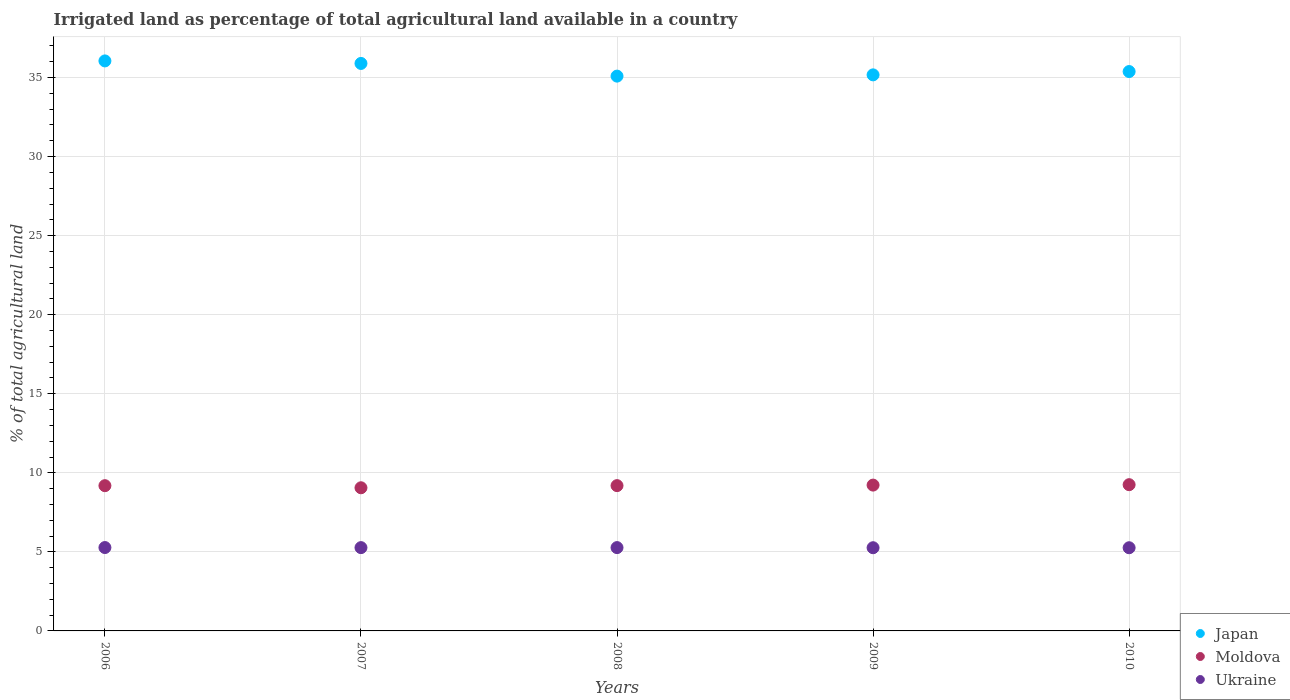How many different coloured dotlines are there?
Give a very brief answer. 3. What is the percentage of irrigated land in Ukraine in 2007?
Provide a succinct answer. 5.27. Across all years, what is the maximum percentage of irrigated land in Ukraine?
Make the answer very short. 5.27. Across all years, what is the minimum percentage of irrigated land in Moldova?
Offer a terse response. 9.05. In which year was the percentage of irrigated land in Japan maximum?
Offer a very short reply. 2006. What is the total percentage of irrigated land in Japan in the graph?
Give a very brief answer. 177.59. What is the difference between the percentage of irrigated land in Ukraine in 2007 and that in 2009?
Keep it short and to the point. 0.01. What is the difference between the percentage of irrigated land in Ukraine in 2007 and the percentage of irrigated land in Japan in 2008?
Your response must be concise. -29.82. What is the average percentage of irrigated land in Moldova per year?
Your response must be concise. 9.18. In the year 2008, what is the difference between the percentage of irrigated land in Japan and percentage of irrigated land in Ukraine?
Offer a very short reply. 29.82. In how many years, is the percentage of irrigated land in Ukraine greater than 32 %?
Offer a very short reply. 0. What is the ratio of the percentage of irrigated land in Moldova in 2009 to that in 2010?
Your answer should be very brief. 1. What is the difference between the highest and the second highest percentage of irrigated land in Moldova?
Your answer should be compact. 0.03. What is the difference between the highest and the lowest percentage of irrigated land in Moldova?
Your answer should be very brief. 0.2. In how many years, is the percentage of irrigated land in Japan greater than the average percentage of irrigated land in Japan taken over all years?
Your answer should be very brief. 2. Is it the case that in every year, the sum of the percentage of irrigated land in Japan and percentage of irrigated land in Ukraine  is greater than the percentage of irrigated land in Moldova?
Give a very brief answer. Yes. Does the percentage of irrigated land in Ukraine monotonically increase over the years?
Your response must be concise. No. Is the percentage of irrigated land in Moldova strictly greater than the percentage of irrigated land in Japan over the years?
Provide a short and direct response. No. How many dotlines are there?
Offer a very short reply. 3. How many years are there in the graph?
Offer a very short reply. 5. What is the difference between two consecutive major ticks on the Y-axis?
Provide a short and direct response. 5. Are the values on the major ticks of Y-axis written in scientific E-notation?
Give a very brief answer. No. Does the graph contain grids?
Offer a very short reply. Yes. Where does the legend appear in the graph?
Provide a succinct answer. Bottom right. What is the title of the graph?
Make the answer very short. Irrigated land as percentage of total agricultural land available in a country. Does "Czech Republic" appear as one of the legend labels in the graph?
Your response must be concise. No. What is the label or title of the X-axis?
Offer a very short reply. Years. What is the label or title of the Y-axis?
Provide a succinct answer. % of total agricultural land. What is the % of total agricultural land in Japan in 2006?
Keep it short and to the point. 36.05. What is the % of total agricultural land in Moldova in 2006?
Make the answer very short. 9.19. What is the % of total agricultural land of Ukraine in 2006?
Provide a succinct answer. 5.27. What is the % of total agricultural land of Japan in 2007?
Provide a succinct answer. 35.89. What is the % of total agricultural land of Moldova in 2007?
Your answer should be compact. 9.05. What is the % of total agricultural land of Ukraine in 2007?
Provide a short and direct response. 5.27. What is the % of total agricultural land in Japan in 2008?
Your answer should be very brief. 35.09. What is the % of total agricultural land in Moldova in 2008?
Your response must be concise. 9.19. What is the % of total agricultural land in Ukraine in 2008?
Make the answer very short. 5.27. What is the % of total agricultural land in Japan in 2009?
Give a very brief answer. 35.17. What is the % of total agricultural land in Moldova in 2009?
Your answer should be compact. 9.22. What is the % of total agricultural land in Ukraine in 2009?
Offer a very short reply. 5.26. What is the % of total agricultural land of Japan in 2010?
Offer a terse response. 35.38. What is the % of total agricultural land in Moldova in 2010?
Offer a terse response. 9.25. What is the % of total agricultural land of Ukraine in 2010?
Your answer should be compact. 5.26. Across all years, what is the maximum % of total agricultural land in Japan?
Offer a very short reply. 36.05. Across all years, what is the maximum % of total agricultural land of Moldova?
Provide a succinct answer. 9.25. Across all years, what is the maximum % of total agricultural land of Ukraine?
Ensure brevity in your answer.  5.27. Across all years, what is the minimum % of total agricultural land in Japan?
Offer a terse response. 35.09. Across all years, what is the minimum % of total agricultural land of Moldova?
Offer a terse response. 9.05. Across all years, what is the minimum % of total agricultural land of Ukraine?
Your response must be concise. 5.26. What is the total % of total agricultural land of Japan in the graph?
Your answer should be compact. 177.59. What is the total % of total agricultural land in Moldova in the graph?
Offer a very short reply. 45.9. What is the total % of total agricultural land of Ukraine in the graph?
Make the answer very short. 26.33. What is the difference between the % of total agricultural land of Japan in 2006 and that in 2007?
Provide a short and direct response. 0.16. What is the difference between the % of total agricultural land in Moldova in 2006 and that in 2007?
Your response must be concise. 0.13. What is the difference between the % of total agricultural land in Ukraine in 2006 and that in 2007?
Your answer should be very brief. 0.01. What is the difference between the % of total agricultural land of Japan in 2006 and that in 2008?
Keep it short and to the point. 0.96. What is the difference between the % of total agricultural land of Moldova in 2006 and that in 2008?
Offer a terse response. -0. What is the difference between the % of total agricultural land in Ukraine in 2006 and that in 2008?
Your answer should be compact. 0. What is the difference between the % of total agricultural land in Japan in 2006 and that in 2009?
Offer a terse response. 0.88. What is the difference between the % of total agricultural land of Moldova in 2006 and that in 2009?
Provide a short and direct response. -0.04. What is the difference between the % of total agricultural land in Ukraine in 2006 and that in 2009?
Your response must be concise. 0.01. What is the difference between the % of total agricultural land in Japan in 2006 and that in 2010?
Offer a very short reply. 0.67. What is the difference between the % of total agricultural land in Moldova in 2006 and that in 2010?
Offer a terse response. -0.06. What is the difference between the % of total agricultural land in Ukraine in 2006 and that in 2010?
Provide a short and direct response. 0.01. What is the difference between the % of total agricultural land of Japan in 2007 and that in 2008?
Offer a very short reply. 0.8. What is the difference between the % of total agricultural land in Moldova in 2007 and that in 2008?
Give a very brief answer. -0.14. What is the difference between the % of total agricultural land of Ukraine in 2007 and that in 2008?
Your answer should be compact. -0. What is the difference between the % of total agricultural land in Japan in 2007 and that in 2009?
Make the answer very short. 0.72. What is the difference between the % of total agricultural land of Moldova in 2007 and that in 2009?
Your answer should be compact. -0.17. What is the difference between the % of total agricultural land of Ukraine in 2007 and that in 2009?
Offer a terse response. 0.01. What is the difference between the % of total agricultural land in Japan in 2007 and that in 2010?
Give a very brief answer. 0.51. What is the difference between the % of total agricultural land of Moldova in 2007 and that in 2010?
Provide a short and direct response. -0.2. What is the difference between the % of total agricultural land in Ukraine in 2007 and that in 2010?
Ensure brevity in your answer.  0.01. What is the difference between the % of total agricultural land in Japan in 2008 and that in 2009?
Ensure brevity in your answer.  -0.08. What is the difference between the % of total agricultural land in Moldova in 2008 and that in 2009?
Offer a terse response. -0.03. What is the difference between the % of total agricultural land of Ukraine in 2008 and that in 2009?
Make the answer very short. 0.01. What is the difference between the % of total agricultural land in Japan in 2008 and that in 2010?
Ensure brevity in your answer.  -0.29. What is the difference between the % of total agricultural land of Moldova in 2008 and that in 2010?
Your response must be concise. -0.06. What is the difference between the % of total agricultural land of Ukraine in 2008 and that in 2010?
Ensure brevity in your answer.  0.01. What is the difference between the % of total agricultural land of Japan in 2009 and that in 2010?
Offer a very short reply. -0.21. What is the difference between the % of total agricultural land in Moldova in 2009 and that in 2010?
Make the answer very short. -0.03. What is the difference between the % of total agricultural land of Ukraine in 2009 and that in 2010?
Give a very brief answer. 0. What is the difference between the % of total agricultural land in Japan in 2006 and the % of total agricultural land in Moldova in 2007?
Your response must be concise. 27. What is the difference between the % of total agricultural land of Japan in 2006 and the % of total agricultural land of Ukraine in 2007?
Make the answer very short. 30.78. What is the difference between the % of total agricultural land in Moldova in 2006 and the % of total agricultural land in Ukraine in 2007?
Offer a very short reply. 3.92. What is the difference between the % of total agricultural land of Japan in 2006 and the % of total agricultural land of Moldova in 2008?
Give a very brief answer. 26.86. What is the difference between the % of total agricultural land of Japan in 2006 and the % of total agricultural land of Ukraine in 2008?
Offer a terse response. 30.78. What is the difference between the % of total agricultural land of Moldova in 2006 and the % of total agricultural land of Ukraine in 2008?
Your response must be concise. 3.92. What is the difference between the % of total agricultural land of Japan in 2006 and the % of total agricultural land of Moldova in 2009?
Your response must be concise. 26.83. What is the difference between the % of total agricultural land of Japan in 2006 and the % of total agricultural land of Ukraine in 2009?
Offer a terse response. 30.79. What is the difference between the % of total agricultural land of Moldova in 2006 and the % of total agricultural land of Ukraine in 2009?
Your answer should be very brief. 3.92. What is the difference between the % of total agricultural land in Japan in 2006 and the % of total agricultural land in Moldova in 2010?
Your answer should be compact. 26.8. What is the difference between the % of total agricultural land of Japan in 2006 and the % of total agricultural land of Ukraine in 2010?
Provide a succinct answer. 30.79. What is the difference between the % of total agricultural land of Moldova in 2006 and the % of total agricultural land of Ukraine in 2010?
Your answer should be compact. 3.93. What is the difference between the % of total agricultural land of Japan in 2007 and the % of total agricultural land of Moldova in 2008?
Offer a terse response. 26.7. What is the difference between the % of total agricultural land in Japan in 2007 and the % of total agricultural land in Ukraine in 2008?
Provide a succinct answer. 30.62. What is the difference between the % of total agricultural land of Moldova in 2007 and the % of total agricultural land of Ukraine in 2008?
Make the answer very short. 3.78. What is the difference between the % of total agricultural land of Japan in 2007 and the % of total agricultural land of Moldova in 2009?
Offer a very short reply. 26.67. What is the difference between the % of total agricultural land of Japan in 2007 and the % of total agricultural land of Ukraine in 2009?
Provide a succinct answer. 30.63. What is the difference between the % of total agricultural land in Moldova in 2007 and the % of total agricultural land in Ukraine in 2009?
Offer a very short reply. 3.79. What is the difference between the % of total agricultural land of Japan in 2007 and the % of total agricultural land of Moldova in 2010?
Offer a terse response. 26.64. What is the difference between the % of total agricultural land in Japan in 2007 and the % of total agricultural land in Ukraine in 2010?
Offer a terse response. 30.63. What is the difference between the % of total agricultural land in Moldova in 2007 and the % of total agricultural land in Ukraine in 2010?
Your answer should be very brief. 3.79. What is the difference between the % of total agricultural land of Japan in 2008 and the % of total agricultural land of Moldova in 2009?
Keep it short and to the point. 25.87. What is the difference between the % of total agricultural land in Japan in 2008 and the % of total agricultural land in Ukraine in 2009?
Give a very brief answer. 29.83. What is the difference between the % of total agricultural land of Moldova in 2008 and the % of total agricultural land of Ukraine in 2009?
Offer a terse response. 3.93. What is the difference between the % of total agricultural land of Japan in 2008 and the % of total agricultural land of Moldova in 2010?
Offer a terse response. 25.84. What is the difference between the % of total agricultural land of Japan in 2008 and the % of total agricultural land of Ukraine in 2010?
Provide a short and direct response. 29.83. What is the difference between the % of total agricultural land of Moldova in 2008 and the % of total agricultural land of Ukraine in 2010?
Give a very brief answer. 3.93. What is the difference between the % of total agricultural land in Japan in 2009 and the % of total agricultural land in Moldova in 2010?
Offer a terse response. 25.92. What is the difference between the % of total agricultural land of Japan in 2009 and the % of total agricultural land of Ukraine in 2010?
Ensure brevity in your answer.  29.91. What is the difference between the % of total agricultural land of Moldova in 2009 and the % of total agricultural land of Ukraine in 2010?
Offer a terse response. 3.96. What is the average % of total agricultural land of Japan per year?
Give a very brief answer. 35.52. What is the average % of total agricultural land in Moldova per year?
Your response must be concise. 9.18. What is the average % of total agricultural land of Ukraine per year?
Your answer should be very brief. 5.27. In the year 2006, what is the difference between the % of total agricultural land in Japan and % of total agricultural land in Moldova?
Provide a short and direct response. 26.87. In the year 2006, what is the difference between the % of total agricultural land of Japan and % of total agricultural land of Ukraine?
Ensure brevity in your answer.  30.78. In the year 2006, what is the difference between the % of total agricultural land of Moldova and % of total agricultural land of Ukraine?
Offer a terse response. 3.91. In the year 2007, what is the difference between the % of total agricultural land of Japan and % of total agricultural land of Moldova?
Your answer should be compact. 26.84. In the year 2007, what is the difference between the % of total agricultural land of Japan and % of total agricultural land of Ukraine?
Offer a terse response. 30.62. In the year 2007, what is the difference between the % of total agricultural land of Moldova and % of total agricultural land of Ukraine?
Your response must be concise. 3.79. In the year 2008, what is the difference between the % of total agricultural land in Japan and % of total agricultural land in Moldova?
Offer a very short reply. 25.9. In the year 2008, what is the difference between the % of total agricultural land of Japan and % of total agricultural land of Ukraine?
Your answer should be very brief. 29.82. In the year 2008, what is the difference between the % of total agricultural land of Moldova and % of total agricultural land of Ukraine?
Your response must be concise. 3.92. In the year 2009, what is the difference between the % of total agricultural land in Japan and % of total agricultural land in Moldova?
Keep it short and to the point. 25.95. In the year 2009, what is the difference between the % of total agricultural land in Japan and % of total agricultural land in Ukraine?
Offer a terse response. 29.91. In the year 2009, what is the difference between the % of total agricultural land of Moldova and % of total agricultural land of Ukraine?
Your response must be concise. 3.96. In the year 2010, what is the difference between the % of total agricultural land in Japan and % of total agricultural land in Moldova?
Keep it short and to the point. 26.13. In the year 2010, what is the difference between the % of total agricultural land of Japan and % of total agricultural land of Ukraine?
Provide a short and direct response. 30.12. In the year 2010, what is the difference between the % of total agricultural land in Moldova and % of total agricultural land in Ukraine?
Give a very brief answer. 3.99. What is the ratio of the % of total agricultural land of Moldova in 2006 to that in 2007?
Make the answer very short. 1.01. What is the ratio of the % of total agricultural land of Ukraine in 2006 to that in 2007?
Your answer should be compact. 1. What is the ratio of the % of total agricultural land of Japan in 2006 to that in 2008?
Your response must be concise. 1.03. What is the ratio of the % of total agricultural land of Moldova in 2006 to that in 2008?
Keep it short and to the point. 1. What is the ratio of the % of total agricultural land of Japan in 2006 to that in 2009?
Your answer should be compact. 1.03. What is the ratio of the % of total agricultural land of Moldova in 2006 to that in 2009?
Your response must be concise. 1. What is the ratio of the % of total agricultural land in Moldova in 2006 to that in 2010?
Offer a very short reply. 0.99. What is the ratio of the % of total agricultural land in Japan in 2007 to that in 2008?
Ensure brevity in your answer.  1.02. What is the ratio of the % of total agricultural land of Japan in 2007 to that in 2009?
Make the answer very short. 1.02. What is the ratio of the % of total agricultural land of Moldova in 2007 to that in 2009?
Make the answer very short. 0.98. What is the ratio of the % of total agricultural land in Ukraine in 2007 to that in 2009?
Offer a very short reply. 1. What is the ratio of the % of total agricultural land of Japan in 2007 to that in 2010?
Your answer should be compact. 1.01. What is the ratio of the % of total agricultural land in Moldova in 2007 to that in 2010?
Provide a succinct answer. 0.98. What is the ratio of the % of total agricultural land in Japan in 2008 to that in 2009?
Offer a terse response. 1. What is the ratio of the % of total agricultural land of Moldova in 2008 to that in 2009?
Ensure brevity in your answer.  1. What is the ratio of the % of total agricultural land of Ukraine in 2008 to that in 2009?
Ensure brevity in your answer.  1. What is the ratio of the % of total agricultural land in Ukraine in 2008 to that in 2010?
Offer a terse response. 1. What is the ratio of the % of total agricultural land of Japan in 2009 to that in 2010?
Offer a very short reply. 0.99. What is the ratio of the % of total agricultural land of Moldova in 2009 to that in 2010?
Your answer should be compact. 1. What is the ratio of the % of total agricultural land in Ukraine in 2009 to that in 2010?
Provide a short and direct response. 1. What is the difference between the highest and the second highest % of total agricultural land in Japan?
Your answer should be compact. 0.16. What is the difference between the highest and the second highest % of total agricultural land in Moldova?
Offer a terse response. 0.03. What is the difference between the highest and the second highest % of total agricultural land of Ukraine?
Keep it short and to the point. 0. What is the difference between the highest and the lowest % of total agricultural land in Japan?
Make the answer very short. 0.96. What is the difference between the highest and the lowest % of total agricultural land in Moldova?
Ensure brevity in your answer.  0.2. What is the difference between the highest and the lowest % of total agricultural land of Ukraine?
Give a very brief answer. 0.01. 